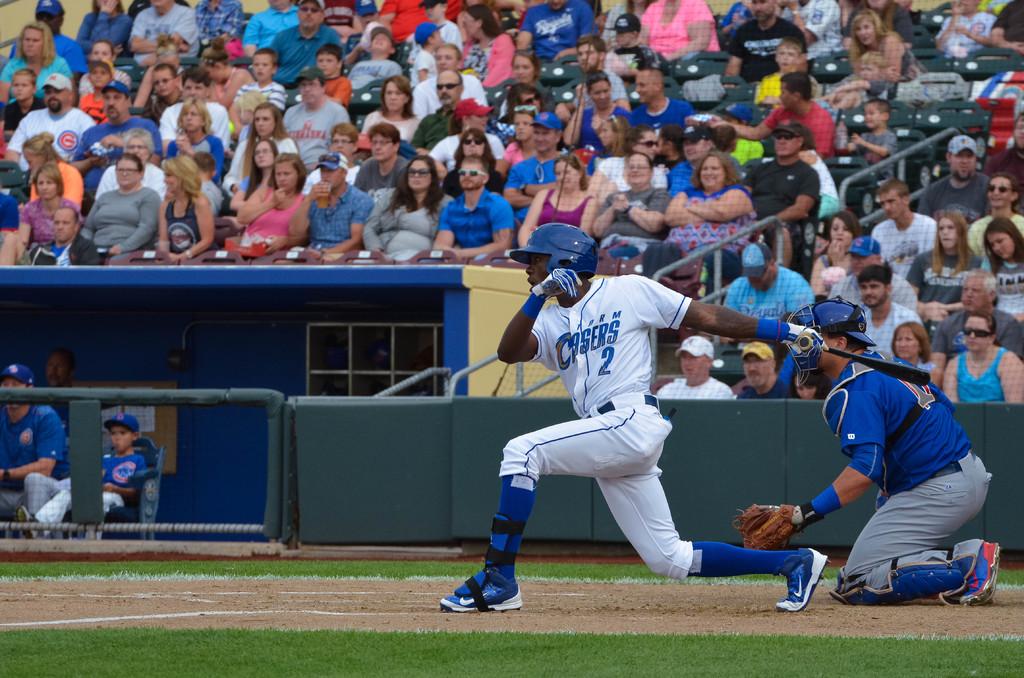What number is the player that has just hit the ball?
Give a very brief answer. 2. What are the last 4 letters of his team's name?
Ensure brevity in your answer.  Sers. 